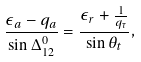<formula> <loc_0><loc_0><loc_500><loc_500>\frac { \epsilon _ { a } - q _ { a } } { \sin \Delta _ { 1 2 } ^ { 0 } } = \frac { \epsilon _ { r } + \frac { 1 } { q _ { \tau } } } { \sin \theta _ { t } } ,</formula> 